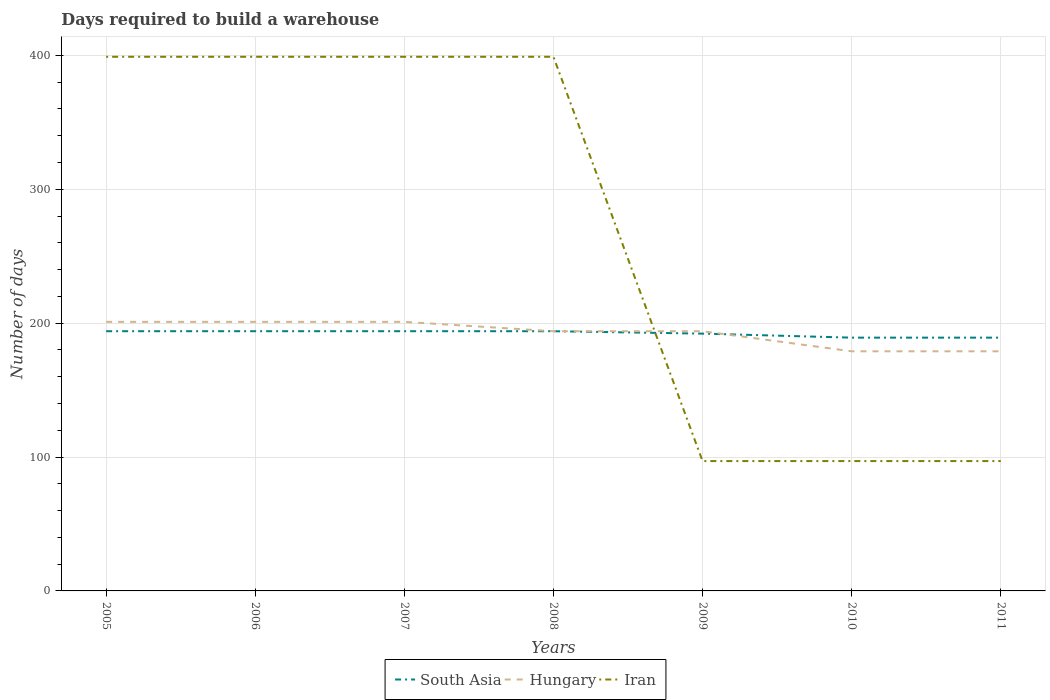How many different coloured lines are there?
Offer a very short reply. 3. Does the line corresponding to Iran intersect with the line corresponding to Hungary?
Offer a very short reply. Yes. Is the number of lines equal to the number of legend labels?
Offer a terse response. Yes. Across all years, what is the maximum days required to build a warehouse in in Iran?
Offer a terse response. 97. In which year was the days required to build a warehouse in in Iran maximum?
Offer a very short reply. 2009. What is the total days required to build a warehouse in in Iran in the graph?
Ensure brevity in your answer.  302. What is the difference between the highest and the second highest days required to build a warehouse in in South Asia?
Provide a short and direct response. 4.8. How many lines are there?
Your response must be concise. 3. How many years are there in the graph?
Provide a short and direct response. 7. What is the difference between two consecutive major ticks on the Y-axis?
Make the answer very short. 100. Are the values on the major ticks of Y-axis written in scientific E-notation?
Ensure brevity in your answer.  No. Does the graph contain grids?
Provide a short and direct response. Yes. How many legend labels are there?
Ensure brevity in your answer.  3. How are the legend labels stacked?
Offer a terse response. Horizontal. What is the title of the graph?
Keep it short and to the point. Days required to build a warehouse. Does "Costa Rica" appear as one of the legend labels in the graph?
Make the answer very short. No. What is the label or title of the X-axis?
Your response must be concise. Years. What is the label or title of the Y-axis?
Keep it short and to the point. Number of days. What is the Number of days of South Asia in 2005?
Your answer should be very brief. 194. What is the Number of days in Hungary in 2005?
Your response must be concise. 201. What is the Number of days in Iran in 2005?
Make the answer very short. 399. What is the Number of days of South Asia in 2006?
Provide a succinct answer. 194. What is the Number of days in Hungary in 2006?
Offer a terse response. 201. What is the Number of days in Iran in 2006?
Your answer should be compact. 399. What is the Number of days in South Asia in 2007?
Your answer should be very brief. 194. What is the Number of days of Hungary in 2007?
Give a very brief answer. 201. What is the Number of days in Iran in 2007?
Offer a terse response. 399. What is the Number of days in South Asia in 2008?
Make the answer very short. 194. What is the Number of days of Hungary in 2008?
Offer a very short reply. 194. What is the Number of days of Iran in 2008?
Your answer should be very brief. 399. What is the Number of days of South Asia in 2009?
Offer a very short reply. 192.2. What is the Number of days in Hungary in 2009?
Offer a terse response. 194. What is the Number of days of Iran in 2009?
Your answer should be compact. 97. What is the Number of days in South Asia in 2010?
Ensure brevity in your answer.  189.2. What is the Number of days of Hungary in 2010?
Provide a succinct answer. 179. What is the Number of days in Iran in 2010?
Make the answer very short. 97. What is the Number of days of South Asia in 2011?
Provide a short and direct response. 189.2. What is the Number of days in Hungary in 2011?
Offer a terse response. 179. What is the Number of days of Iran in 2011?
Offer a very short reply. 97. Across all years, what is the maximum Number of days in South Asia?
Give a very brief answer. 194. Across all years, what is the maximum Number of days of Hungary?
Your answer should be compact. 201. Across all years, what is the maximum Number of days of Iran?
Make the answer very short. 399. Across all years, what is the minimum Number of days of South Asia?
Provide a succinct answer. 189.2. Across all years, what is the minimum Number of days of Hungary?
Provide a succinct answer. 179. Across all years, what is the minimum Number of days in Iran?
Ensure brevity in your answer.  97. What is the total Number of days in South Asia in the graph?
Provide a succinct answer. 1346.6. What is the total Number of days of Hungary in the graph?
Your answer should be very brief. 1349. What is the total Number of days in Iran in the graph?
Ensure brevity in your answer.  1887. What is the difference between the Number of days of South Asia in 2005 and that in 2007?
Your answer should be compact. 0. What is the difference between the Number of days of Iran in 2005 and that in 2007?
Provide a succinct answer. 0. What is the difference between the Number of days of South Asia in 2005 and that in 2008?
Keep it short and to the point. 0. What is the difference between the Number of days of Hungary in 2005 and that in 2008?
Offer a very short reply. 7. What is the difference between the Number of days in Iran in 2005 and that in 2008?
Make the answer very short. 0. What is the difference between the Number of days in Hungary in 2005 and that in 2009?
Make the answer very short. 7. What is the difference between the Number of days in Iran in 2005 and that in 2009?
Offer a terse response. 302. What is the difference between the Number of days of South Asia in 2005 and that in 2010?
Make the answer very short. 4.8. What is the difference between the Number of days in Hungary in 2005 and that in 2010?
Offer a terse response. 22. What is the difference between the Number of days in Iran in 2005 and that in 2010?
Offer a very short reply. 302. What is the difference between the Number of days of South Asia in 2005 and that in 2011?
Provide a succinct answer. 4.8. What is the difference between the Number of days in Iran in 2005 and that in 2011?
Give a very brief answer. 302. What is the difference between the Number of days in Hungary in 2006 and that in 2007?
Offer a terse response. 0. What is the difference between the Number of days in Iran in 2006 and that in 2007?
Offer a terse response. 0. What is the difference between the Number of days of South Asia in 2006 and that in 2008?
Ensure brevity in your answer.  0. What is the difference between the Number of days of Hungary in 2006 and that in 2008?
Your answer should be compact. 7. What is the difference between the Number of days of Iran in 2006 and that in 2009?
Your answer should be very brief. 302. What is the difference between the Number of days in Iran in 2006 and that in 2010?
Offer a terse response. 302. What is the difference between the Number of days in Hungary in 2006 and that in 2011?
Give a very brief answer. 22. What is the difference between the Number of days in Iran in 2006 and that in 2011?
Make the answer very short. 302. What is the difference between the Number of days of South Asia in 2007 and that in 2008?
Offer a terse response. 0. What is the difference between the Number of days of Hungary in 2007 and that in 2008?
Make the answer very short. 7. What is the difference between the Number of days of Iran in 2007 and that in 2009?
Provide a short and direct response. 302. What is the difference between the Number of days in Hungary in 2007 and that in 2010?
Keep it short and to the point. 22. What is the difference between the Number of days of Iran in 2007 and that in 2010?
Offer a very short reply. 302. What is the difference between the Number of days of South Asia in 2007 and that in 2011?
Give a very brief answer. 4.8. What is the difference between the Number of days in Hungary in 2007 and that in 2011?
Ensure brevity in your answer.  22. What is the difference between the Number of days of Iran in 2007 and that in 2011?
Offer a very short reply. 302. What is the difference between the Number of days of Hungary in 2008 and that in 2009?
Provide a short and direct response. 0. What is the difference between the Number of days of Iran in 2008 and that in 2009?
Offer a terse response. 302. What is the difference between the Number of days of South Asia in 2008 and that in 2010?
Your answer should be very brief. 4.8. What is the difference between the Number of days of Iran in 2008 and that in 2010?
Provide a short and direct response. 302. What is the difference between the Number of days in South Asia in 2008 and that in 2011?
Your answer should be very brief. 4.8. What is the difference between the Number of days in Hungary in 2008 and that in 2011?
Ensure brevity in your answer.  15. What is the difference between the Number of days in Iran in 2008 and that in 2011?
Make the answer very short. 302. What is the difference between the Number of days of South Asia in 2009 and that in 2010?
Provide a succinct answer. 3. What is the difference between the Number of days in Iran in 2009 and that in 2010?
Ensure brevity in your answer.  0. What is the difference between the Number of days of South Asia in 2009 and that in 2011?
Make the answer very short. 3. What is the difference between the Number of days of Hungary in 2009 and that in 2011?
Provide a succinct answer. 15. What is the difference between the Number of days in South Asia in 2005 and the Number of days in Hungary in 2006?
Ensure brevity in your answer.  -7. What is the difference between the Number of days in South Asia in 2005 and the Number of days in Iran in 2006?
Ensure brevity in your answer.  -205. What is the difference between the Number of days in Hungary in 2005 and the Number of days in Iran in 2006?
Your answer should be very brief. -198. What is the difference between the Number of days of South Asia in 2005 and the Number of days of Iran in 2007?
Keep it short and to the point. -205. What is the difference between the Number of days in Hungary in 2005 and the Number of days in Iran in 2007?
Provide a succinct answer. -198. What is the difference between the Number of days in South Asia in 2005 and the Number of days in Iran in 2008?
Offer a very short reply. -205. What is the difference between the Number of days in Hungary in 2005 and the Number of days in Iran in 2008?
Your answer should be compact. -198. What is the difference between the Number of days in South Asia in 2005 and the Number of days in Hungary in 2009?
Keep it short and to the point. 0. What is the difference between the Number of days in South Asia in 2005 and the Number of days in Iran in 2009?
Provide a short and direct response. 97. What is the difference between the Number of days of Hungary in 2005 and the Number of days of Iran in 2009?
Provide a short and direct response. 104. What is the difference between the Number of days of South Asia in 2005 and the Number of days of Hungary in 2010?
Make the answer very short. 15. What is the difference between the Number of days in South Asia in 2005 and the Number of days in Iran in 2010?
Provide a succinct answer. 97. What is the difference between the Number of days in Hungary in 2005 and the Number of days in Iran in 2010?
Offer a very short reply. 104. What is the difference between the Number of days in South Asia in 2005 and the Number of days in Iran in 2011?
Ensure brevity in your answer.  97. What is the difference between the Number of days in Hungary in 2005 and the Number of days in Iran in 2011?
Your answer should be very brief. 104. What is the difference between the Number of days in South Asia in 2006 and the Number of days in Iran in 2007?
Keep it short and to the point. -205. What is the difference between the Number of days of Hungary in 2006 and the Number of days of Iran in 2007?
Your response must be concise. -198. What is the difference between the Number of days of South Asia in 2006 and the Number of days of Hungary in 2008?
Ensure brevity in your answer.  0. What is the difference between the Number of days in South Asia in 2006 and the Number of days in Iran in 2008?
Provide a succinct answer. -205. What is the difference between the Number of days of Hungary in 2006 and the Number of days of Iran in 2008?
Provide a succinct answer. -198. What is the difference between the Number of days in South Asia in 2006 and the Number of days in Hungary in 2009?
Offer a very short reply. 0. What is the difference between the Number of days in South Asia in 2006 and the Number of days in Iran in 2009?
Offer a terse response. 97. What is the difference between the Number of days of Hungary in 2006 and the Number of days of Iran in 2009?
Provide a short and direct response. 104. What is the difference between the Number of days in South Asia in 2006 and the Number of days in Iran in 2010?
Provide a succinct answer. 97. What is the difference between the Number of days of Hungary in 2006 and the Number of days of Iran in 2010?
Offer a very short reply. 104. What is the difference between the Number of days of South Asia in 2006 and the Number of days of Hungary in 2011?
Ensure brevity in your answer.  15. What is the difference between the Number of days of South Asia in 2006 and the Number of days of Iran in 2011?
Keep it short and to the point. 97. What is the difference between the Number of days in Hungary in 2006 and the Number of days in Iran in 2011?
Your answer should be very brief. 104. What is the difference between the Number of days in South Asia in 2007 and the Number of days in Iran in 2008?
Provide a succinct answer. -205. What is the difference between the Number of days in Hungary in 2007 and the Number of days in Iran in 2008?
Ensure brevity in your answer.  -198. What is the difference between the Number of days of South Asia in 2007 and the Number of days of Hungary in 2009?
Your response must be concise. 0. What is the difference between the Number of days of South Asia in 2007 and the Number of days of Iran in 2009?
Provide a short and direct response. 97. What is the difference between the Number of days of Hungary in 2007 and the Number of days of Iran in 2009?
Your answer should be very brief. 104. What is the difference between the Number of days in South Asia in 2007 and the Number of days in Iran in 2010?
Offer a terse response. 97. What is the difference between the Number of days of Hungary in 2007 and the Number of days of Iran in 2010?
Offer a very short reply. 104. What is the difference between the Number of days of South Asia in 2007 and the Number of days of Hungary in 2011?
Give a very brief answer. 15. What is the difference between the Number of days of South Asia in 2007 and the Number of days of Iran in 2011?
Keep it short and to the point. 97. What is the difference between the Number of days in Hungary in 2007 and the Number of days in Iran in 2011?
Provide a short and direct response. 104. What is the difference between the Number of days of South Asia in 2008 and the Number of days of Hungary in 2009?
Ensure brevity in your answer.  0. What is the difference between the Number of days in South Asia in 2008 and the Number of days in Iran in 2009?
Give a very brief answer. 97. What is the difference between the Number of days in Hungary in 2008 and the Number of days in Iran in 2009?
Give a very brief answer. 97. What is the difference between the Number of days of South Asia in 2008 and the Number of days of Hungary in 2010?
Your answer should be compact. 15. What is the difference between the Number of days in South Asia in 2008 and the Number of days in Iran in 2010?
Offer a very short reply. 97. What is the difference between the Number of days in Hungary in 2008 and the Number of days in Iran in 2010?
Keep it short and to the point. 97. What is the difference between the Number of days of South Asia in 2008 and the Number of days of Hungary in 2011?
Provide a short and direct response. 15. What is the difference between the Number of days in South Asia in 2008 and the Number of days in Iran in 2011?
Keep it short and to the point. 97. What is the difference between the Number of days of Hungary in 2008 and the Number of days of Iran in 2011?
Make the answer very short. 97. What is the difference between the Number of days in South Asia in 2009 and the Number of days in Iran in 2010?
Keep it short and to the point. 95.2. What is the difference between the Number of days in Hungary in 2009 and the Number of days in Iran in 2010?
Keep it short and to the point. 97. What is the difference between the Number of days of South Asia in 2009 and the Number of days of Iran in 2011?
Your response must be concise. 95.2. What is the difference between the Number of days in Hungary in 2009 and the Number of days in Iran in 2011?
Your answer should be compact. 97. What is the difference between the Number of days in South Asia in 2010 and the Number of days in Iran in 2011?
Make the answer very short. 92.2. What is the difference between the Number of days in Hungary in 2010 and the Number of days in Iran in 2011?
Give a very brief answer. 82. What is the average Number of days of South Asia per year?
Provide a succinct answer. 192.37. What is the average Number of days in Hungary per year?
Provide a short and direct response. 192.71. What is the average Number of days of Iran per year?
Make the answer very short. 269.57. In the year 2005, what is the difference between the Number of days in South Asia and Number of days in Iran?
Offer a terse response. -205. In the year 2005, what is the difference between the Number of days of Hungary and Number of days of Iran?
Your answer should be very brief. -198. In the year 2006, what is the difference between the Number of days of South Asia and Number of days of Iran?
Provide a short and direct response. -205. In the year 2006, what is the difference between the Number of days in Hungary and Number of days in Iran?
Your response must be concise. -198. In the year 2007, what is the difference between the Number of days in South Asia and Number of days in Iran?
Your response must be concise. -205. In the year 2007, what is the difference between the Number of days in Hungary and Number of days in Iran?
Your answer should be compact. -198. In the year 2008, what is the difference between the Number of days in South Asia and Number of days in Hungary?
Offer a terse response. 0. In the year 2008, what is the difference between the Number of days in South Asia and Number of days in Iran?
Your answer should be very brief. -205. In the year 2008, what is the difference between the Number of days in Hungary and Number of days in Iran?
Provide a succinct answer. -205. In the year 2009, what is the difference between the Number of days in South Asia and Number of days in Iran?
Your response must be concise. 95.2. In the year 2009, what is the difference between the Number of days of Hungary and Number of days of Iran?
Provide a short and direct response. 97. In the year 2010, what is the difference between the Number of days in South Asia and Number of days in Iran?
Ensure brevity in your answer.  92.2. In the year 2010, what is the difference between the Number of days in Hungary and Number of days in Iran?
Ensure brevity in your answer.  82. In the year 2011, what is the difference between the Number of days of South Asia and Number of days of Iran?
Ensure brevity in your answer.  92.2. What is the ratio of the Number of days of Hungary in 2005 to that in 2006?
Provide a short and direct response. 1. What is the ratio of the Number of days of South Asia in 2005 to that in 2007?
Your answer should be compact. 1. What is the ratio of the Number of days of Hungary in 2005 to that in 2007?
Your response must be concise. 1. What is the ratio of the Number of days of Hungary in 2005 to that in 2008?
Your answer should be very brief. 1.04. What is the ratio of the Number of days of Iran in 2005 to that in 2008?
Your answer should be very brief. 1. What is the ratio of the Number of days of South Asia in 2005 to that in 2009?
Offer a very short reply. 1.01. What is the ratio of the Number of days of Hungary in 2005 to that in 2009?
Make the answer very short. 1.04. What is the ratio of the Number of days in Iran in 2005 to that in 2009?
Ensure brevity in your answer.  4.11. What is the ratio of the Number of days of South Asia in 2005 to that in 2010?
Give a very brief answer. 1.03. What is the ratio of the Number of days in Hungary in 2005 to that in 2010?
Keep it short and to the point. 1.12. What is the ratio of the Number of days of Iran in 2005 to that in 2010?
Ensure brevity in your answer.  4.11. What is the ratio of the Number of days of South Asia in 2005 to that in 2011?
Offer a terse response. 1.03. What is the ratio of the Number of days of Hungary in 2005 to that in 2011?
Your response must be concise. 1.12. What is the ratio of the Number of days of Iran in 2005 to that in 2011?
Offer a very short reply. 4.11. What is the ratio of the Number of days in South Asia in 2006 to that in 2007?
Your response must be concise. 1. What is the ratio of the Number of days of Hungary in 2006 to that in 2007?
Your response must be concise. 1. What is the ratio of the Number of days of South Asia in 2006 to that in 2008?
Make the answer very short. 1. What is the ratio of the Number of days of Hungary in 2006 to that in 2008?
Offer a very short reply. 1.04. What is the ratio of the Number of days of Iran in 2006 to that in 2008?
Your response must be concise. 1. What is the ratio of the Number of days in South Asia in 2006 to that in 2009?
Make the answer very short. 1.01. What is the ratio of the Number of days of Hungary in 2006 to that in 2009?
Provide a succinct answer. 1.04. What is the ratio of the Number of days in Iran in 2006 to that in 2009?
Offer a terse response. 4.11. What is the ratio of the Number of days of South Asia in 2006 to that in 2010?
Your answer should be very brief. 1.03. What is the ratio of the Number of days of Hungary in 2006 to that in 2010?
Make the answer very short. 1.12. What is the ratio of the Number of days in Iran in 2006 to that in 2010?
Provide a short and direct response. 4.11. What is the ratio of the Number of days in South Asia in 2006 to that in 2011?
Give a very brief answer. 1.03. What is the ratio of the Number of days of Hungary in 2006 to that in 2011?
Your response must be concise. 1.12. What is the ratio of the Number of days in Iran in 2006 to that in 2011?
Your response must be concise. 4.11. What is the ratio of the Number of days in Hungary in 2007 to that in 2008?
Your response must be concise. 1.04. What is the ratio of the Number of days of South Asia in 2007 to that in 2009?
Your answer should be very brief. 1.01. What is the ratio of the Number of days of Hungary in 2007 to that in 2009?
Keep it short and to the point. 1.04. What is the ratio of the Number of days in Iran in 2007 to that in 2009?
Your answer should be compact. 4.11. What is the ratio of the Number of days of South Asia in 2007 to that in 2010?
Offer a terse response. 1.03. What is the ratio of the Number of days of Hungary in 2007 to that in 2010?
Provide a succinct answer. 1.12. What is the ratio of the Number of days in Iran in 2007 to that in 2010?
Offer a very short reply. 4.11. What is the ratio of the Number of days of South Asia in 2007 to that in 2011?
Provide a short and direct response. 1.03. What is the ratio of the Number of days in Hungary in 2007 to that in 2011?
Offer a very short reply. 1.12. What is the ratio of the Number of days of Iran in 2007 to that in 2011?
Your answer should be very brief. 4.11. What is the ratio of the Number of days of South Asia in 2008 to that in 2009?
Ensure brevity in your answer.  1.01. What is the ratio of the Number of days of Iran in 2008 to that in 2009?
Make the answer very short. 4.11. What is the ratio of the Number of days in South Asia in 2008 to that in 2010?
Your answer should be very brief. 1.03. What is the ratio of the Number of days of Hungary in 2008 to that in 2010?
Keep it short and to the point. 1.08. What is the ratio of the Number of days in Iran in 2008 to that in 2010?
Provide a short and direct response. 4.11. What is the ratio of the Number of days of South Asia in 2008 to that in 2011?
Provide a short and direct response. 1.03. What is the ratio of the Number of days of Hungary in 2008 to that in 2011?
Offer a very short reply. 1.08. What is the ratio of the Number of days in Iran in 2008 to that in 2011?
Your answer should be compact. 4.11. What is the ratio of the Number of days in South Asia in 2009 to that in 2010?
Your answer should be compact. 1.02. What is the ratio of the Number of days in Hungary in 2009 to that in 2010?
Your answer should be compact. 1.08. What is the ratio of the Number of days of South Asia in 2009 to that in 2011?
Provide a short and direct response. 1.02. What is the ratio of the Number of days in Hungary in 2009 to that in 2011?
Make the answer very short. 1.08. What is the ratio of the Number of days in Hungary in 2010 to that in 2011?
Your answer should be very brief. 1. What is the ratio of the Number of days of Iran in 2010 to that in 2011?
Your response must be concise. 1. What is the difference between the highest and the second highest Number of days in South Asia?
Your answer should be compact. 0. What is the difference between the highest and the second highest Number of days in Iran?
Keep it short and to the point. 0. What is the difference between the highest and the lowest Number of days of Iran?
Provide a short and direct response. 302. 